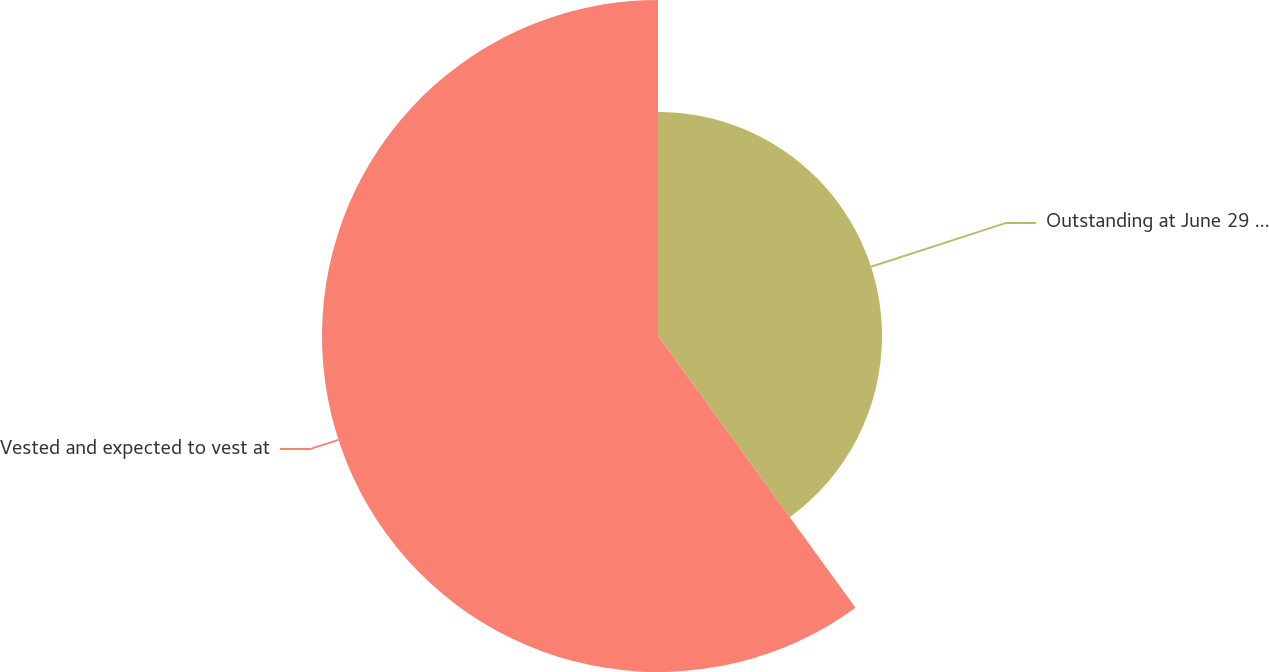Convert chart. <chart><loc_0><loc_0><loc_500><loc_500><pie_chart><fcel>Outstanding at June 29 2007<fcel>Vested and expected to vest at<nl><fcel>40.0%<fcel>60.0%<nl></chart> 